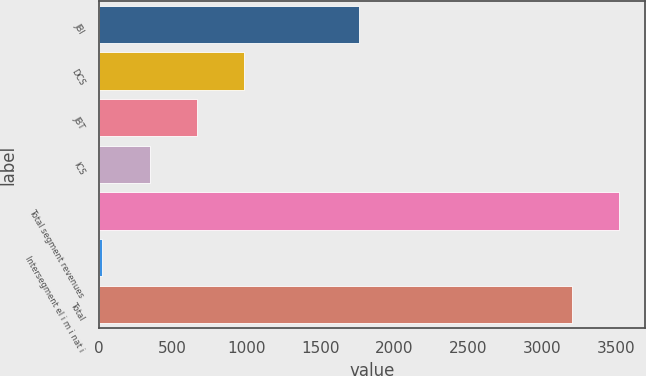Convert chart. <chart><loc_0><loc_0><loc_500><loc_500><bar_chart><fcel>JBI<fcel>DCS<fcel>JBT<fcel>ICS<fcel>Total segment revenues<fcel>Intersegment el i m i nat i<fcel>Total<nl><fcel>1764<fcel>984.9<fcel>664.6<fcel>344.3<fcel>3523.3<fcel>24<fcel>3203<nl></chart> 